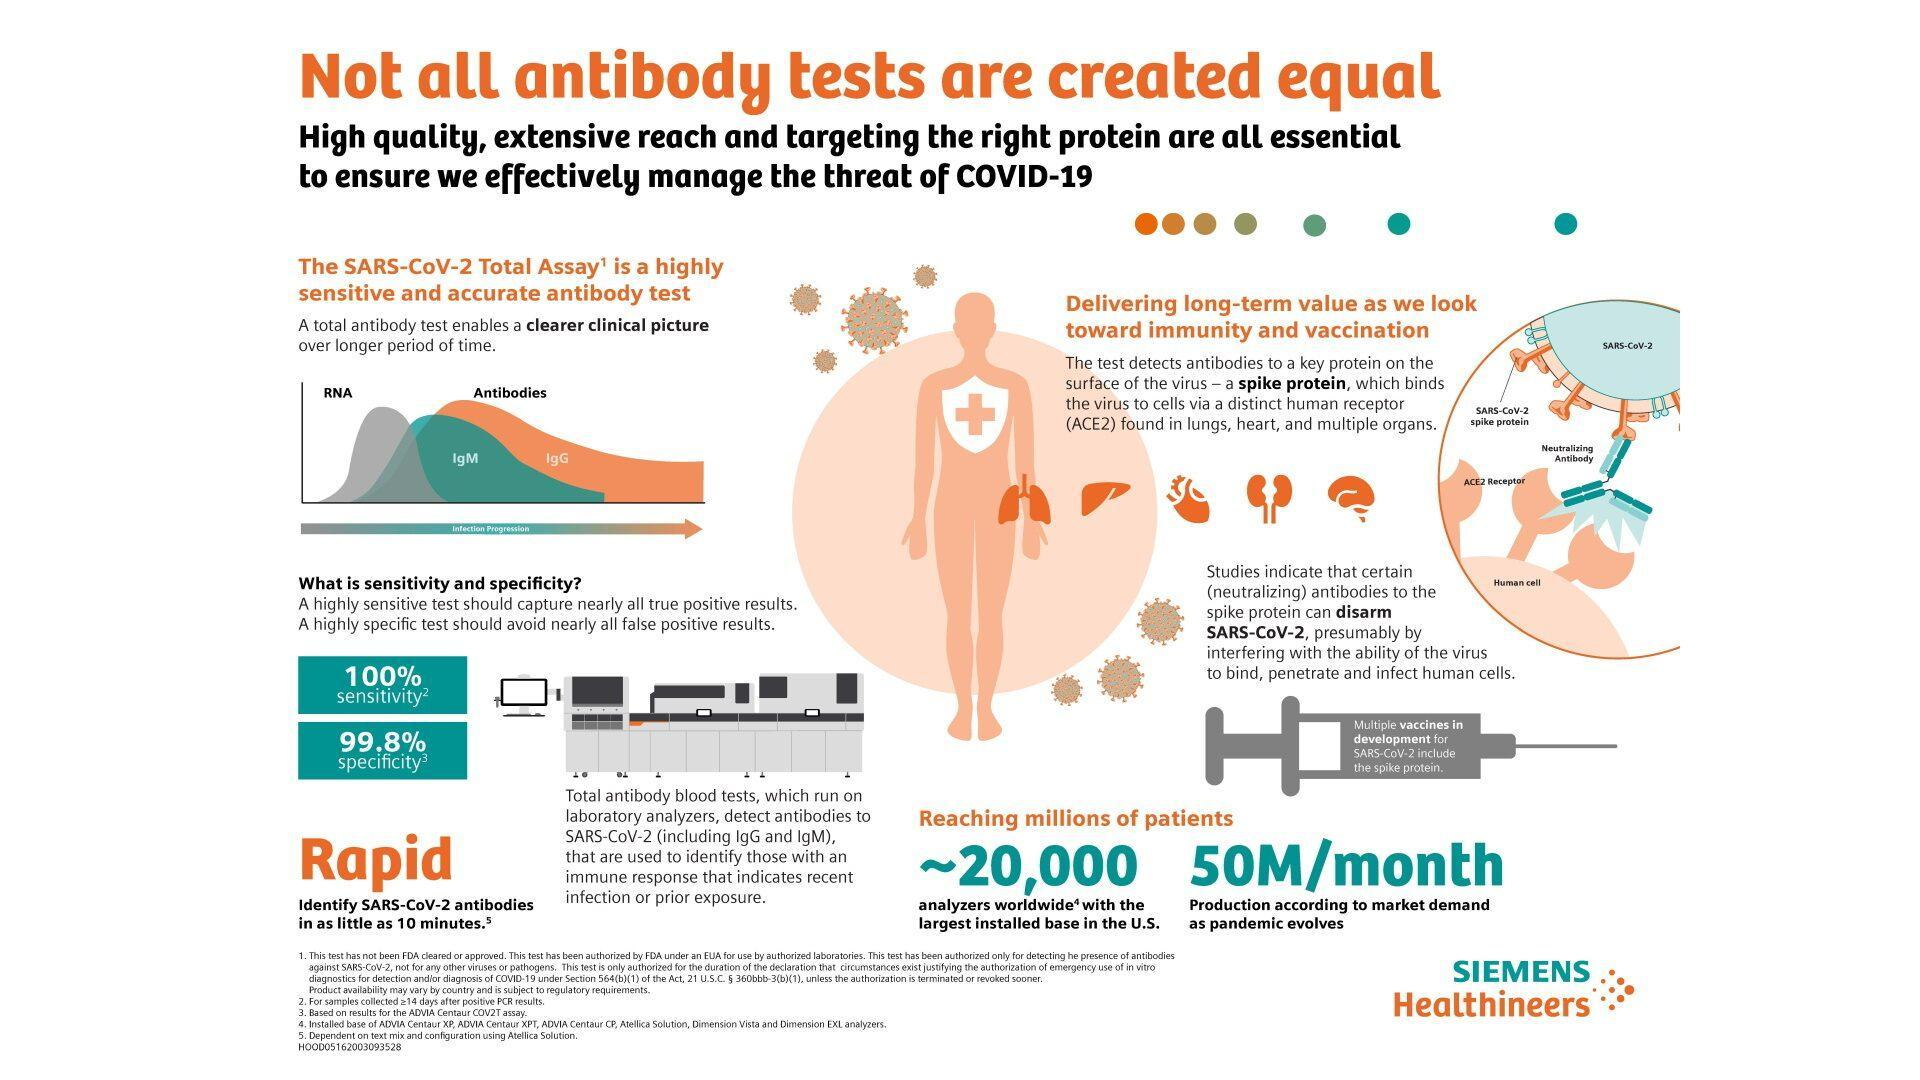What is the sensitivity of SARS-CoV-2 Total Assay?
Answer the question with a short phrase. 100% Through which receptor does the spike protein bind the virus to the cells? ACE2 What is the specificity of SARS-CoV-2 Total Assay? 99.8% How many analyzers are produced each month as the pandemic evolves? 50M What is the name of the analyzer that is capable of identifying antibodies within 10 minutes? Rapid What do the multiple vaccines in the development for SARS-COV2 include? Spike protein How many analyzers have been installed worldwide? 20,000 